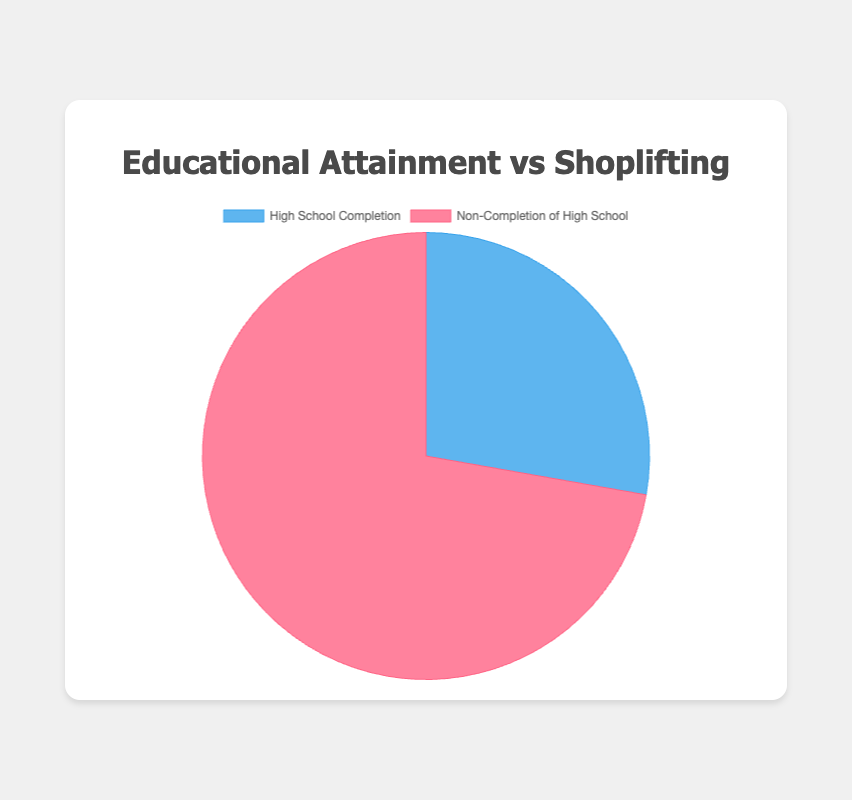What percentage of people who completed high school are involved in shoplifting? Refer to the pie chart segment representing "High School Completion" and find the data point for the percentage involved in shoplifting.
Answer: 25% How much more likely are individuals who did not complete high school to be involved in shoplifting compared to those who did complete high school? Calculate the difference between the percentages of individuals involved in shoplifting for "Non-Completion of High School" (65%) and "High School Completion" (25%).
Answer: 40% What proportion of individuals who did not complete high school are not involved in shoplifting? Identify the data point for the percentage not involved in shoplifting from the "Non-Completion of High School" section.
Answer: 35% Compare the percentage of individuals who are not involved in shoplifting between those who did and did not complete high school. Find and compare the segments in the pie chart for "Percentage Not Involved in Shoplifting" for both groups: 75% for high school completers and 35% for non-completers.
Answer: 75% vs 35% Which group has a higher percentage of individuals involved in shoplifting? Look at the pie chart and compare the two segments for "Percentage Involved in Shoplifting". "Non-Completion of High School" has 65%, while "High School Completion" has 25%.
Answer: Non-Completion of High School What is the difference between the percentage of individuals not involved in shoplifting who completed high school and those who didn’t? Subtract the percentage of non-completers not involved in shoplifting (35%) from the percentage of completers not involved in shoplifting (75%).
Answer: 40% What is the total percentage represented by individuals either involved or not involved in shoplifting who completed high school? Add the percentages for "Percentage Involved in Shoplifting" and "Percentage Not Involved in Shoplifting" for high school completers: 25% + 75% = 100%.
Answer: 100% What color represents the group of individuals who completed high school in the pie chart? Look at the pie chart segment for "High School Completion" and identify its color, which is blue.
Answer: Blue 